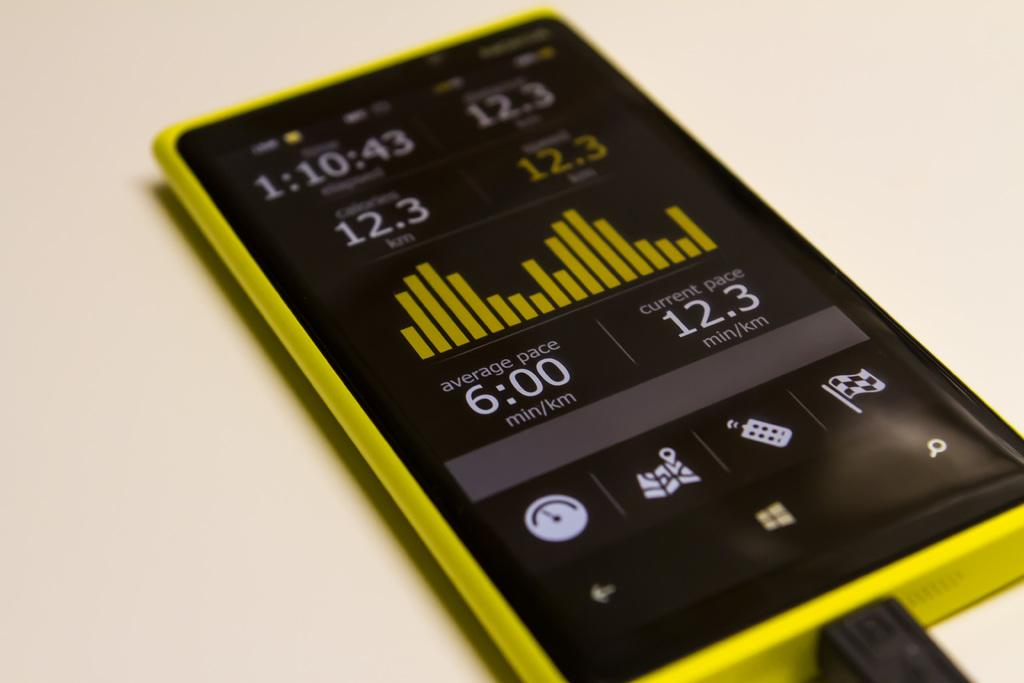<image>
Summarize the visual content of the image. an old looking phone showing 6.00 as the time. 